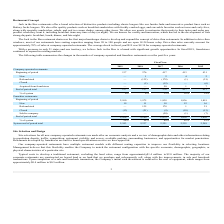According to Jack In The Box's financial document, What was the average check for comapny-operated restaurants in fiscal year 2019? According to the financial document, $8.34. The relevant text states: "aurants. The average check in fiscal year 2019 was $8.34 for company-operated restaurants...." Also, What percentage of sales at company-operated restaurants are from drive-thru sales? According to the financial document, approximately 70%. The relevant text states: "ours a day. Drive-thru sales currently account for approximately 70% of sales at company-operated restaurants. The average check in fiscal year 2019 was $8.34 for compan..." Also, For company-operated restaurants, what is the end of period total in fiscal year 2019? According to the financial document, 137. The relevant text states: "Beginning of period 137 276 417 413 431..." Also, can you calculate: What is the difference in the number of company-operated restaurants between 2017 and 2018 at end of period total?  Based on the calculation: 276 - 137 , the result is 139. This is based on the information: "Beginning of period 137 276 417 413 431 Beginning of period 137 276 417 413 431..." The key data points involved are: 137, 276. Also, can you calculate: For franchise restaurants, what is the average end of period total for 2018 and 2019? To answer this question, I need to perform calculations using the financial data. The calculation is: (2,106 + 2,100)/2 , which equals 2103. This is based on the information: "End of period total 2,106 2,100 1,975 1,838 1,836 End of period total 2,106 2,100 1,975 1,838 1,836..." The key data points involved are: 2,100, 2,106. Also, can you calculate: For franchise restaurants, what is the percentage increase of end of period total from 2015 to 2016? To answer this question, I need to perform calculations using the financial data. The calculation is: (1,838 - 1,836)/ 1,836 , which equals 0.11 (percentage). This is based on the information: "Beginning of period 2,100 1,975 1,838 1,836 1,819 Beginning of period 2,100 1,975 1,838 1,836 1,819..." The key data points involved are: 1,836, 1,838. 